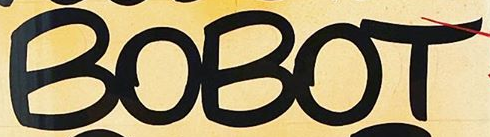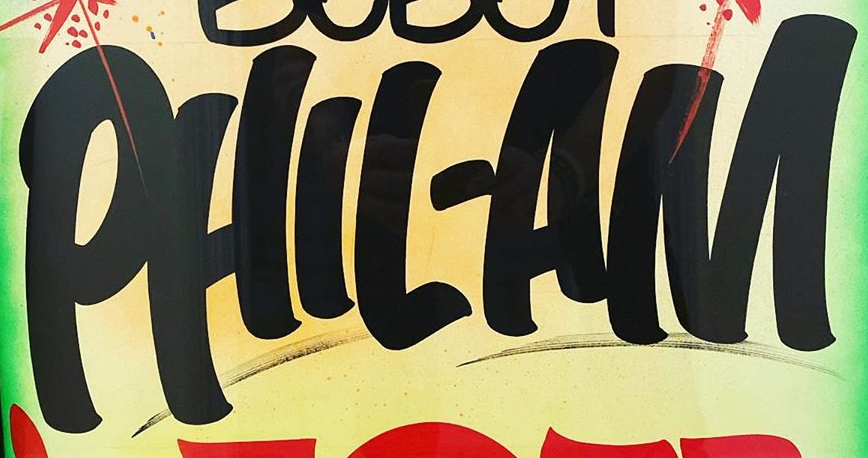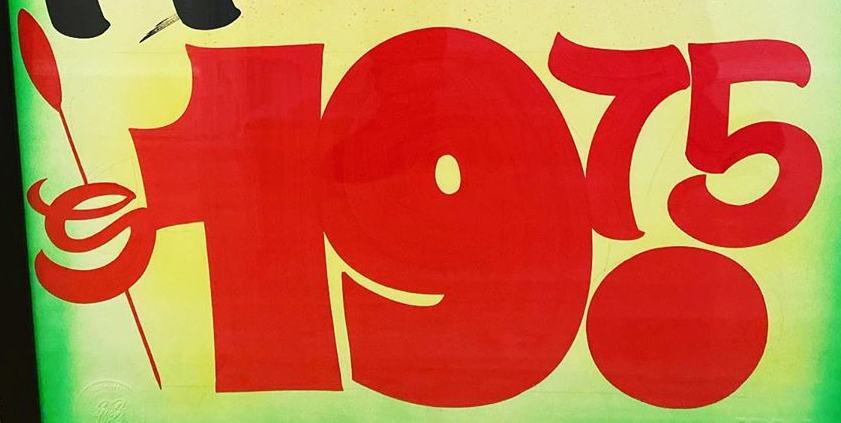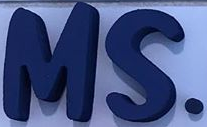Read the text from these images in sequence, separated by a semicolon. BOBOT; PHIL-AM; $19.75; MS. 